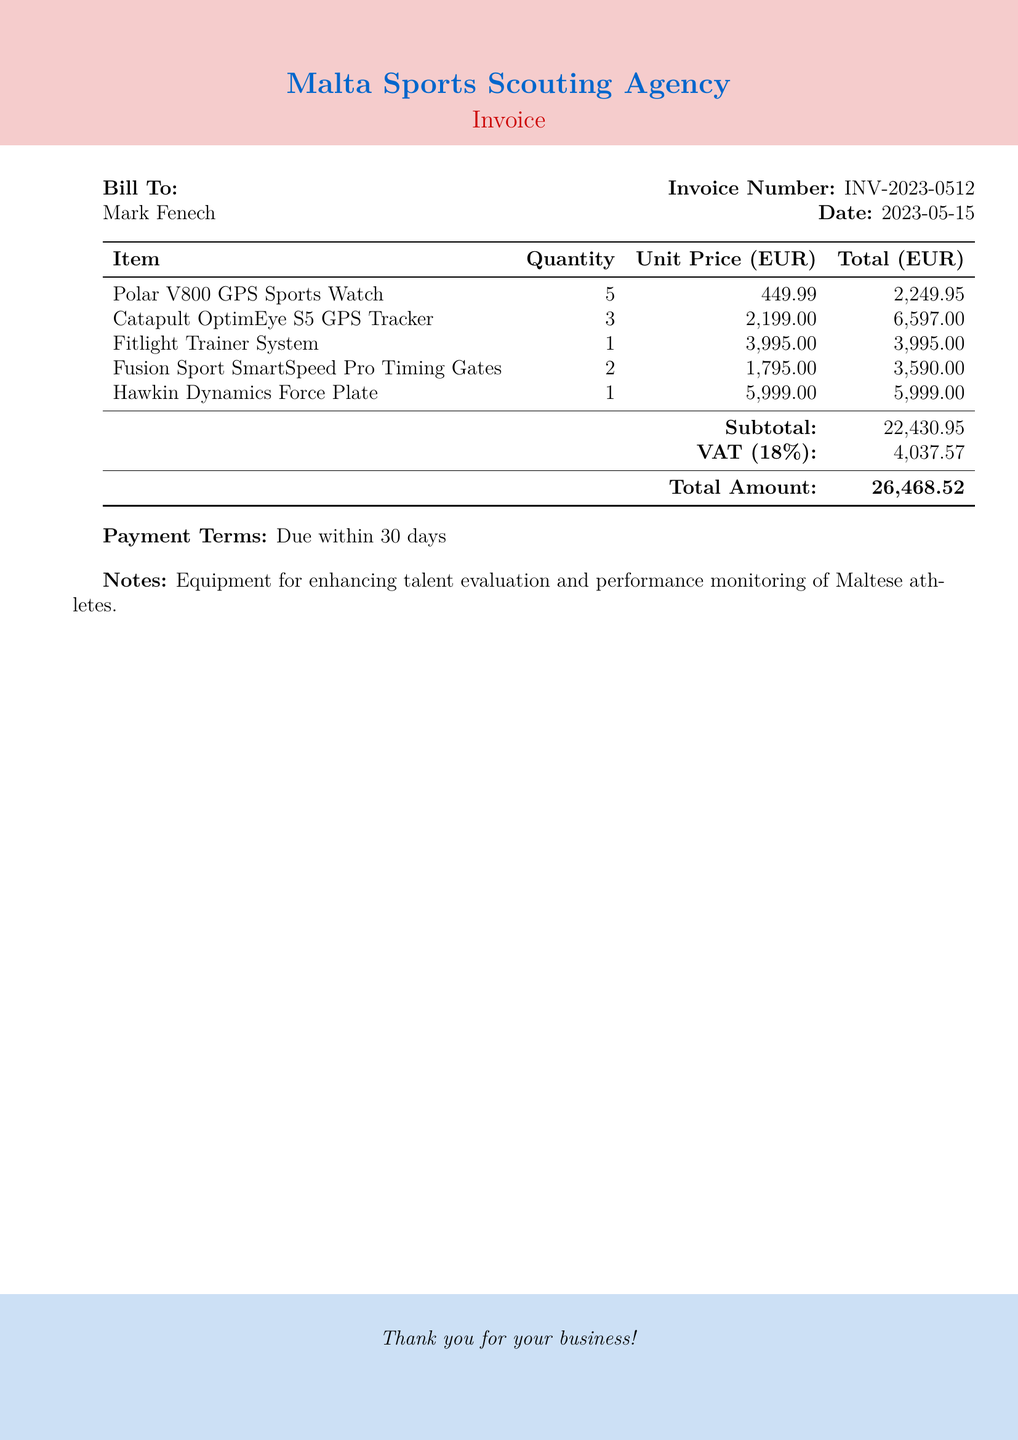What is the invoice number? The invoice number is clearly stated in the document as part of the header section.
Answer: INV-2023-0512 Who is the bill addressed to? The bill specifies the recipient under the "Bill To" section, identifying the individual or organization to which the invoice is sent.
Answer: Mark Fenech What is the date of the bill? The date is explicitly mentioned near the invoice number, representing when the bill was issued.
Answer: 2023-05-15 How many Catapult OptimEye S5 GPS Trackers were purchased? The quantity of this item is noted in the itemized list, reflecting how many units were acquired.
Answer: 3 What is the total amount due? The total amount due is calculated and provided at the bottom of the invoice, summarizing the overall cost including VAT.
Answer: 26,468.52 What is the VAT percentage applied? The VAT percentage is indicated in the subtotal section, detailing the tax rate included in the final amount.
Answer: 18% What equipment system is used for timing? The document lists various items purchased, including the specific system aimed at timing during performance evaluation.
Answer: Fusion Sport SmartSpeed Pro Timing Gates What is the subtotal before VAT? The subtotal is shown right before the VAT calculation and represents the total amount before tax is applied.
Answer: 22,430.95 What are the payment terms specified? Payment terms inform the recipient when payment is expected and are noted at the end of the document.
Answer: Due within 30 days 